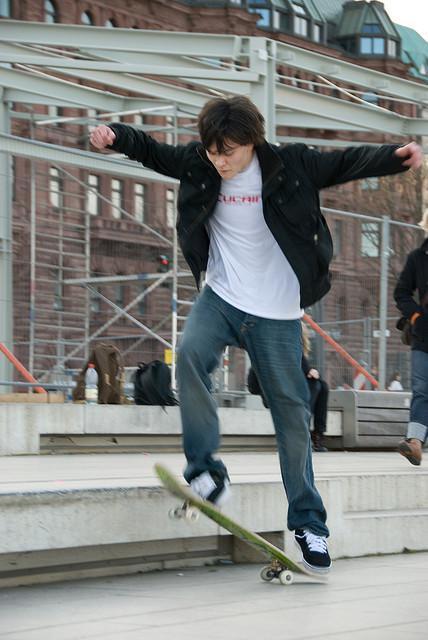How many people are there?
Give a very brief answer. 2. How many train cars are under the poles?
Give a very brief answer. 0. 